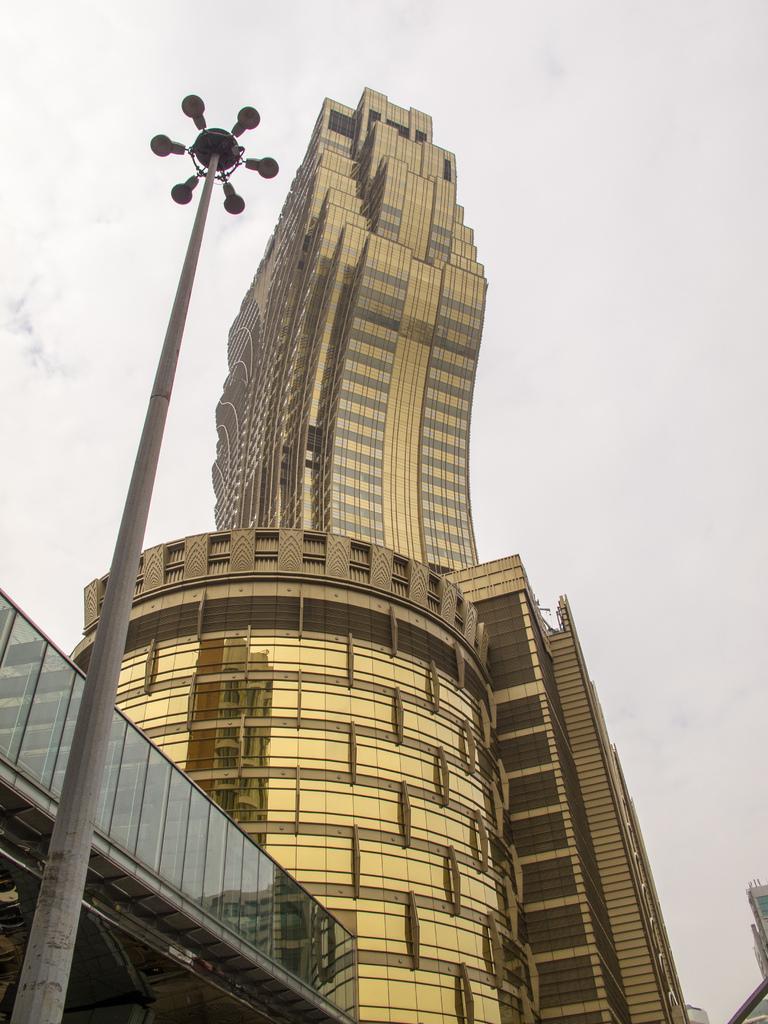Can you describe this image briefly? In the center of the image there is a building. There is a street light. At the top of the image there is sky. 